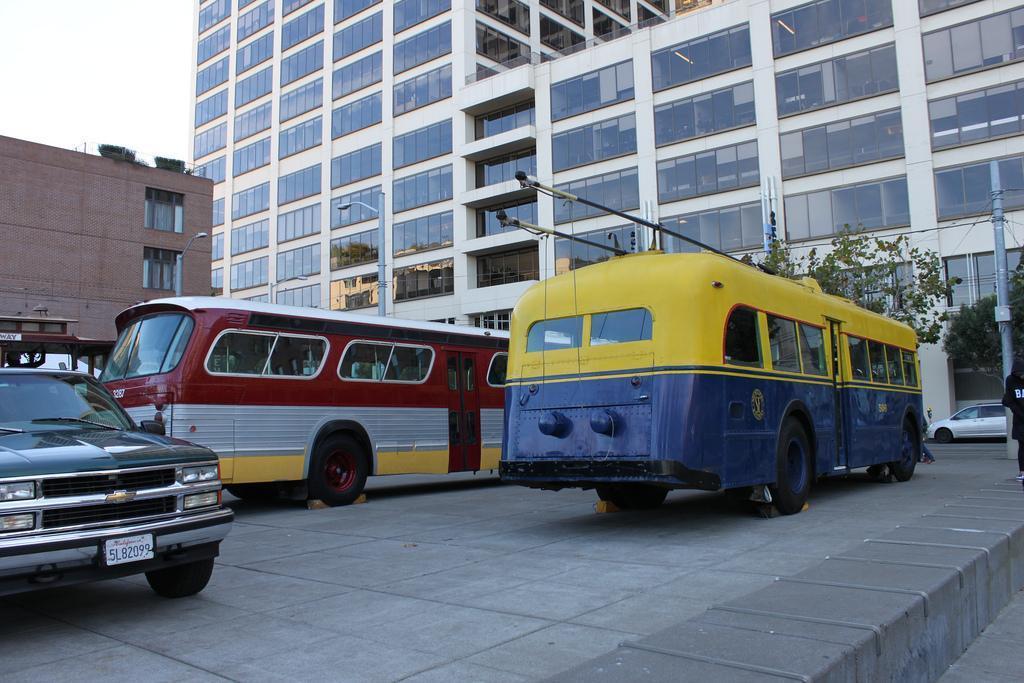How many vehicles are not buses?
Give a very brief answer. 2. 